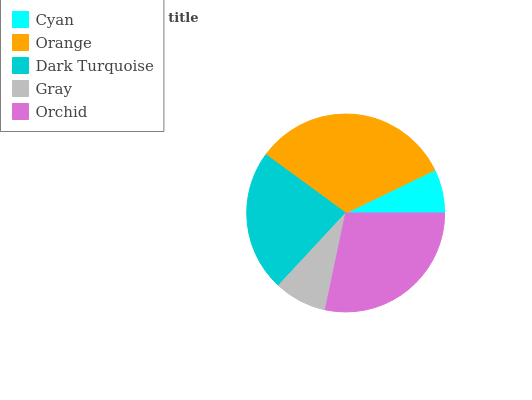Is Cyan the minimum?
Answer yes or no. Yes. Is Orange the maximum?
Answer yes or no. Yes. Is Dark Turquoise the minimum?
Answer yes or no. No. Is Dark Turquoise the maximum?
Answer yes or no. No. Is Orange greater than Dark Turquoise?
Answer yes or no. Yes. Is Dark Turquoise less than Orange?
Answer yes or no. Yes. Is Dark Turquoise greater than Orange?
Answer yes or no. No. Is Orange less than Dark Turquoise?
Answer yes or no. No. Is Dark Turquoise the high median?
Answer yes or no. Yes. Is Dark Turquoise the low median?
Answer yes or no. Yes. Is Cyan the high median?
Answer yes or no. No. Is Orchid the low median?
Answer yes or no. No. 